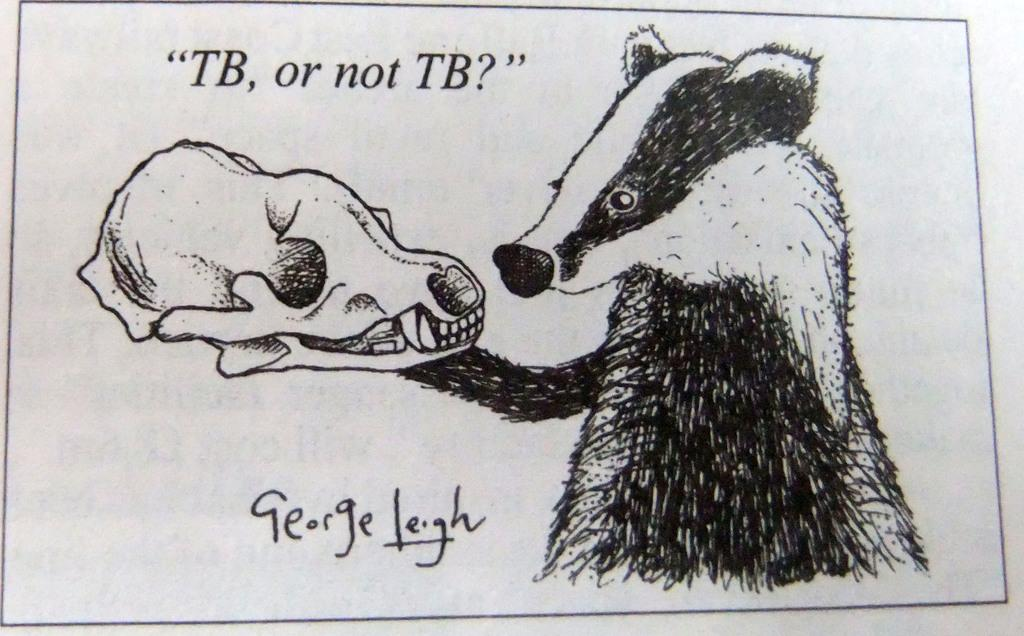What is the main subject of the painting in the image? There is a painting of an animal in the image. What other element is depicted alongside the painting? There is a skeleton depicted in the image. Are there any words or letters in the image? Yes, there is text present in the image. What can be inferred about the origin of the image? The image appears to be taken from a book. What type of cloud can be seen in the image? There are no clouds present in the image; it features a painting of an animal and a skeleton. Can you describe the street where the trucks are parked in the image? There are no streets or trucks depicted in the image. 